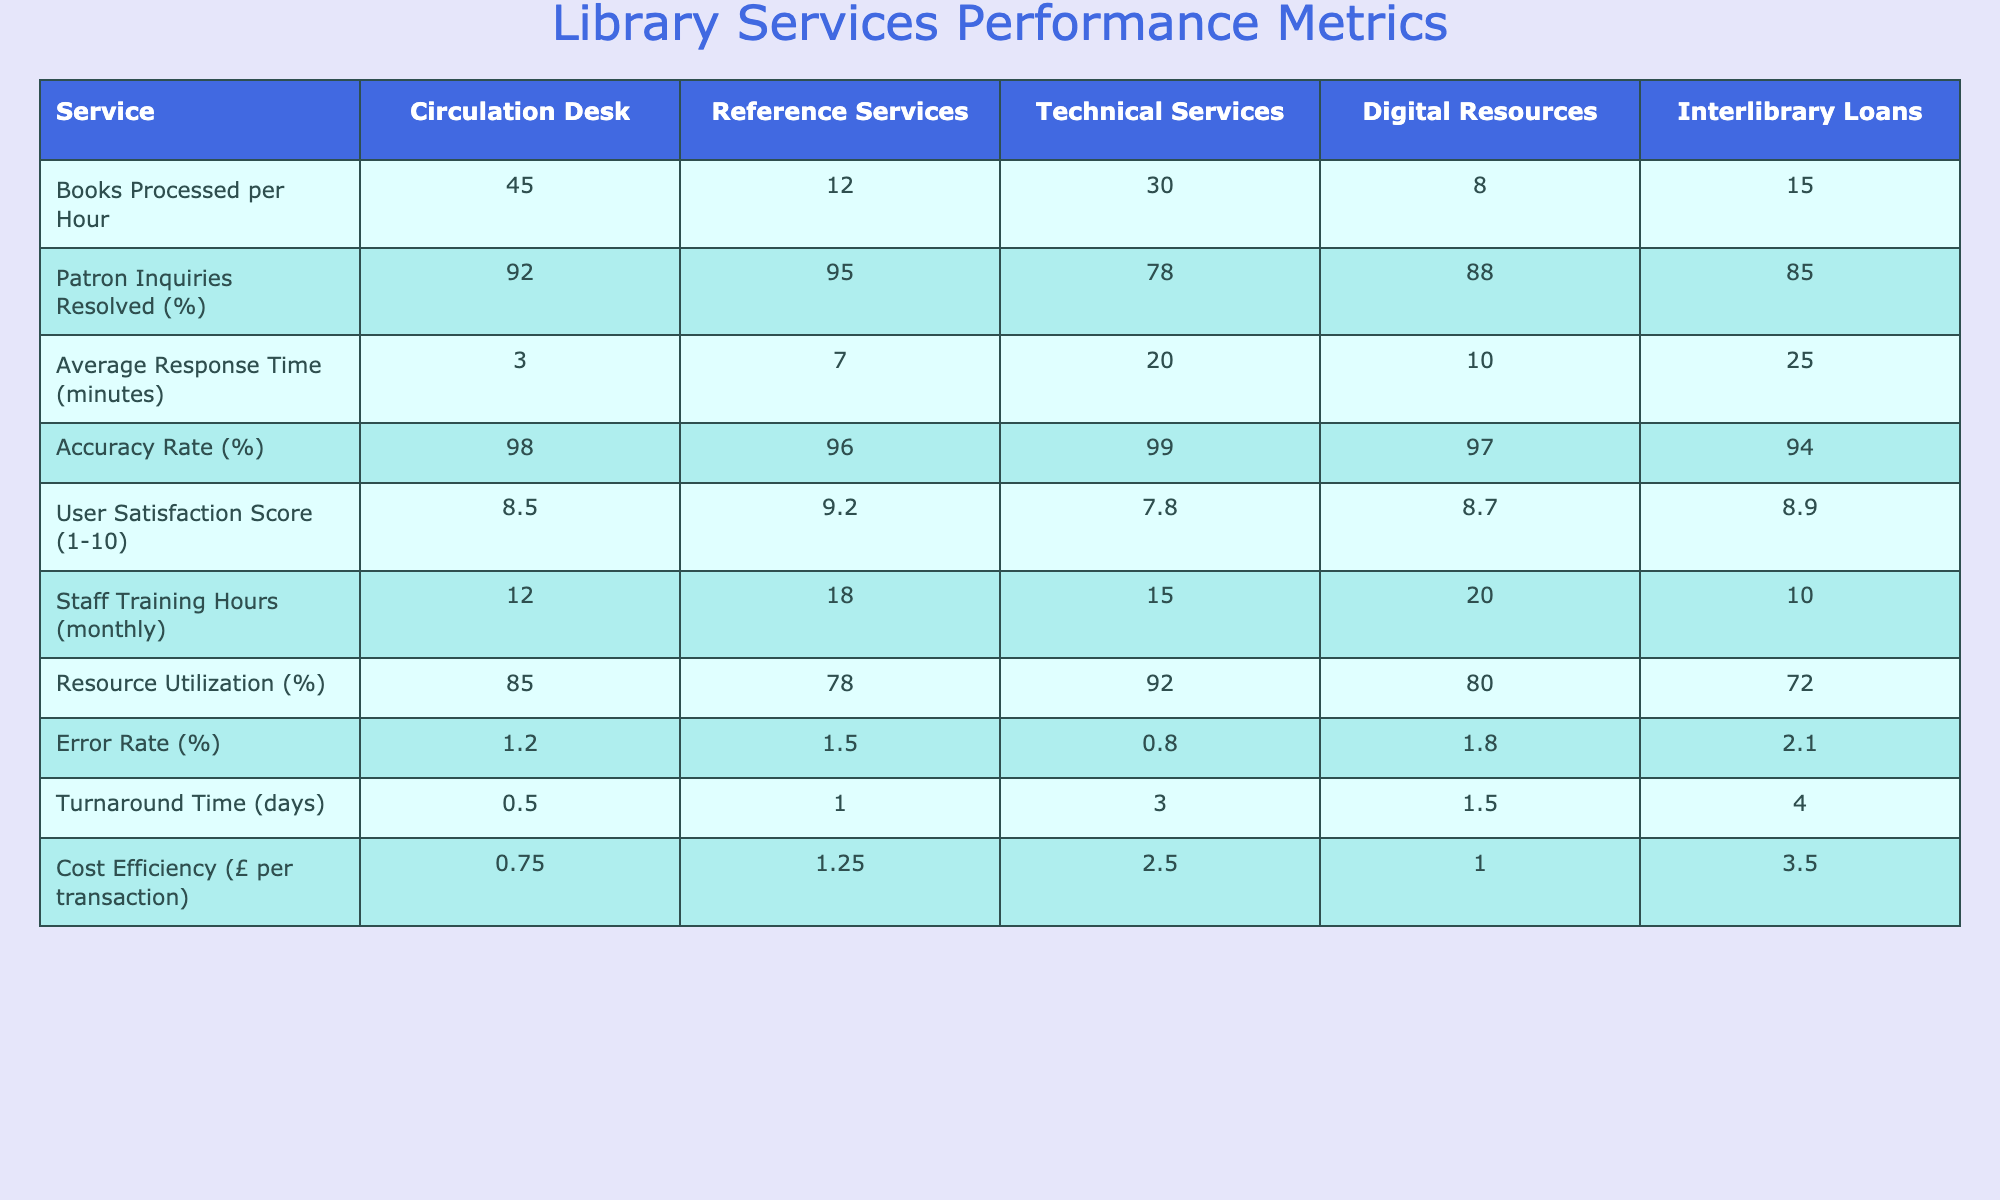What is the average user satisfaction score across all services? To find the average user satisfaction score, we sum up all the scores: (8.5 + 9.2 + 7.8 + 8.7 + 8.9) = 43.1. Then, we divide by the number of services, which is 5. Thus, the average score is 43.1 / 5 = 8.62.
Answer: 8.62 What service has the highest accuracy rate? By examining the accuracy rates for each service, we find that Technical Services has the highest accuracy rate of 99%.
Answer: Technical Services How many books are processed per hour at the Circulation Desk? The table shows that the Circulation Desk processes 45 books per hour.
Answer: 45 Is the error rate for Interlibrary Loans higher than that for Digital Resources? The error rate for Interlibrary Loans is 2.1%, while Digital Resources has an error rate of 1.8%. Since 2.1% is greater than 1.8%, the statement is true.
Answer: Yes What is the total number of training hours for all services combined? We total the training hours for each service: (12 + 18 + 15 + 20 + 10) = 75.
Answer: 75 What is the difference in patron inquiries resolved percentage between Reference Services and Technical Services? Reference Services resolved 95% of inquiries while Technical Services resolved 78%. The difference is calculated as 95 - 78 = 17%.
Answer: 17% Which service has the longest average response time? The average response times listed indicate that Interlibrary Loans, with 25 minutes, has the longest response time among the services.
Answer: Interlibrary Loans If we consider only the services with a cost efficiency lower than £2 per transaction, how many services are there? We identify the cost efficiencies below £2: Circulation Desk (£0.75), Digital Resources (£1.00), and Reference Services (£1.25). This totals 3 services.
Answer: 3 What is the ratio of books processed per hour at the Technical Services to that at the Digital Resources? The Technical Services process 30 books per hour, whereas Digital Resources process 8 books. The ratio is therefore 30:8, which simplifies to 15:4.
Answer: 15:4 Which service has the highest resource utilization percentage? Upon reviewing the resource utilization percentages, Technical Services has the highest utilization at 92%.
Answer: Technical Services 